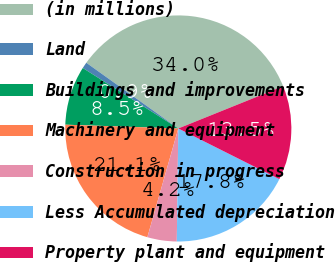Convert chart to OTSL. <chart><loc_0><loc_0><loc_500><loc_500><pie_chart><fcel>(in millions)<fcel>Land<fcel>Buildings and improvements<fcel>Machinery and equipment<fcel>Construction in progress<fcel>Less Accumulated depreciation<fcel>Property plant and equipment<nl><fcel>34.03%<fcel>0.89%<fcel>8.45%<fcel>21.12%<fcel>4.2%<fcel>17.81%<fcel>13.5%<nl></chart> 